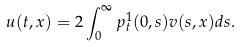<formula> <loc_0><loc_0><loc_500><loc_500>u ( t , x ) = 2 \int _ { 0 } ^ { \infty } p _ { t } ^ { 1 } ( 0 , s ) v ( s , x ) d s .</formula> 